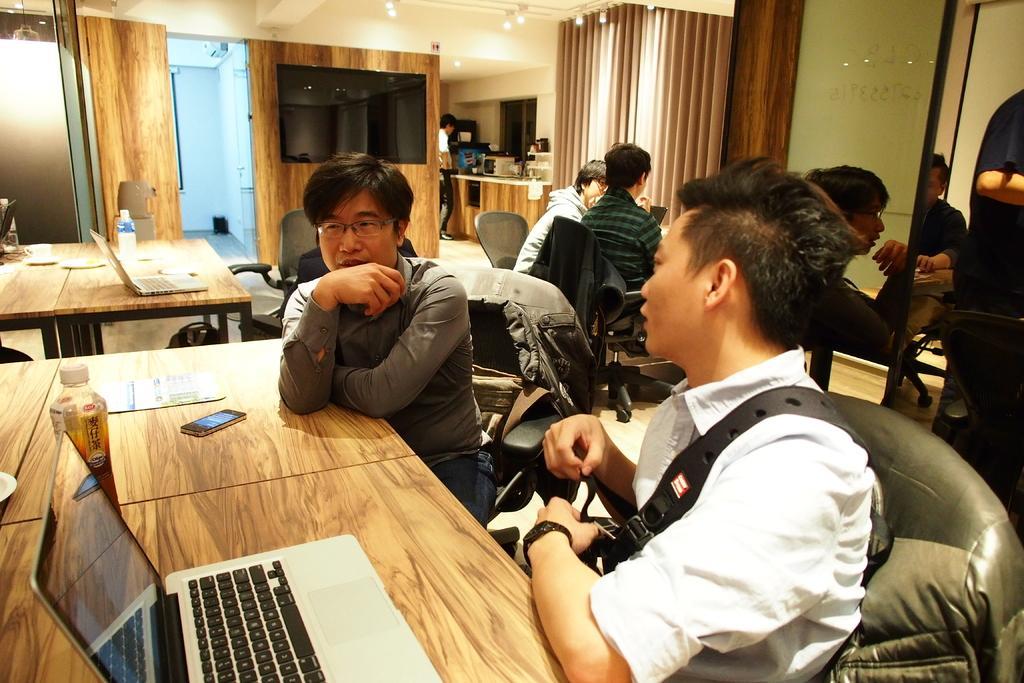Please provide a concise description of this image. In this picture there are many people those who are sitting on the chairs, there is a person who is sitting at the right side of the image is talking to the person who is sitting beside him and there is a bottle, cell phone and a laptop on the table, there is a counter at the right side of the image and there is a television at the center of the image, there are other people those sitting around the area. 